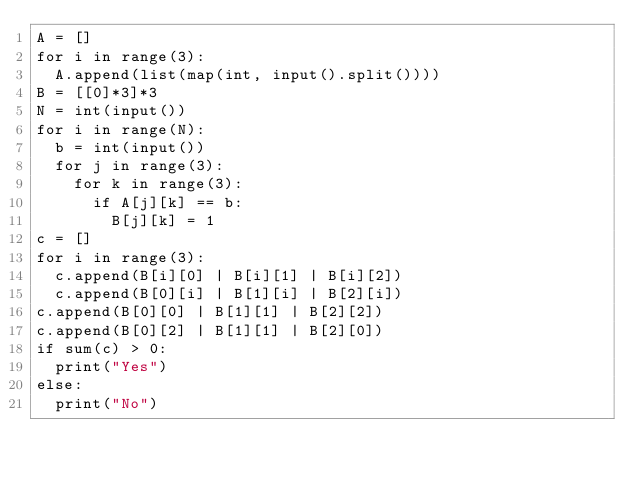Convert code to text. <code><loc_0><loc_0><loc_500><loc_500><_Python_>A = []
for i in range(3):
  A.append(list(map(int, input().split())))
B = [[0]*3]*3
N = int(input())
for i in range(N):
  b = int(input())
  for j in range(3):
    for k in range(3):
      if A[j][k] == b:
        B[j][k] = 1
c = []
for i in range(3):
  c.append(B[i][0] | B[i][1] | B[i][2])
  c.append(B[0][i] | B[1][i] | B[2][i])
c.append(B[0][0] | B[1][1] | B[2][2])
c.append(B[0][2] | B[1][1] | B[2][0])
if sum(c) > 0:
  print("Yes")
else:
  print("No")</code> 